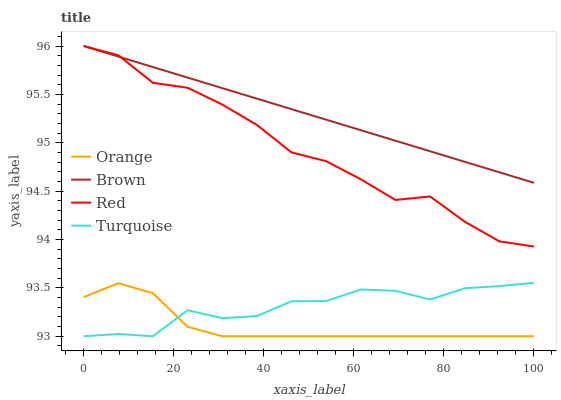Does Orange have the minimum area under the curve?
Answer yes or no. Yes. Does Brown have the maximum area under the curve?
Answer yes or no. Yes. Does Turquoise have the minimum area under the curve?
Answer yes or no. No. Does Turquoise have the maximum area under the curve?
Answer yes or no. No. Is Brown the smoothest?
Answer yes or no. Yes. Is Red the roughest?
Answer yes or no. Yes. Is Turquoise the smoothest?
Answer yes or no. No. Is Turquoise the roughest?
Answer yes or no. No. Does Orange have the lowest value?
Answer yes or no. Yes. Does Brown have the lowest value?
Answer yes or no. No. Does Red have the highest value?
Answer yes or no. Yes. Does Turquoise have the highest value?
Answer yes or no. No. Is Orange less than Brown?
Answer yes or no. Yes. Is Red greater than Turquoise?
Answer yes or no. Yes. Does Red intersect Brown?
Answer yes or no. Yes. Is Red less than Brown?
Answer yes or no. No. Is Red greater than Brown?
Answer yes or no. No. Does Orange intersect Brown?
Answer yes or no. No. 